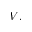Convert formula to latex. <formula><loc_0><loc_0><loc_500><loc_500>V .</formula> 